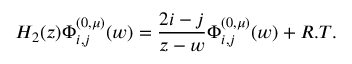Convert formula to latex. <formula><loc_0><loc_0><loc_500><loc_500>H _ { 2 } ( z ) \Phi _ { i , j } ^ { ( 0 , \mu ) } ( w ) = \frac { 2 i - j } { z - w } \Phi _ { i , j } ^ { ( 0 , \mu ) } ( w ) + R . T .</formula> 